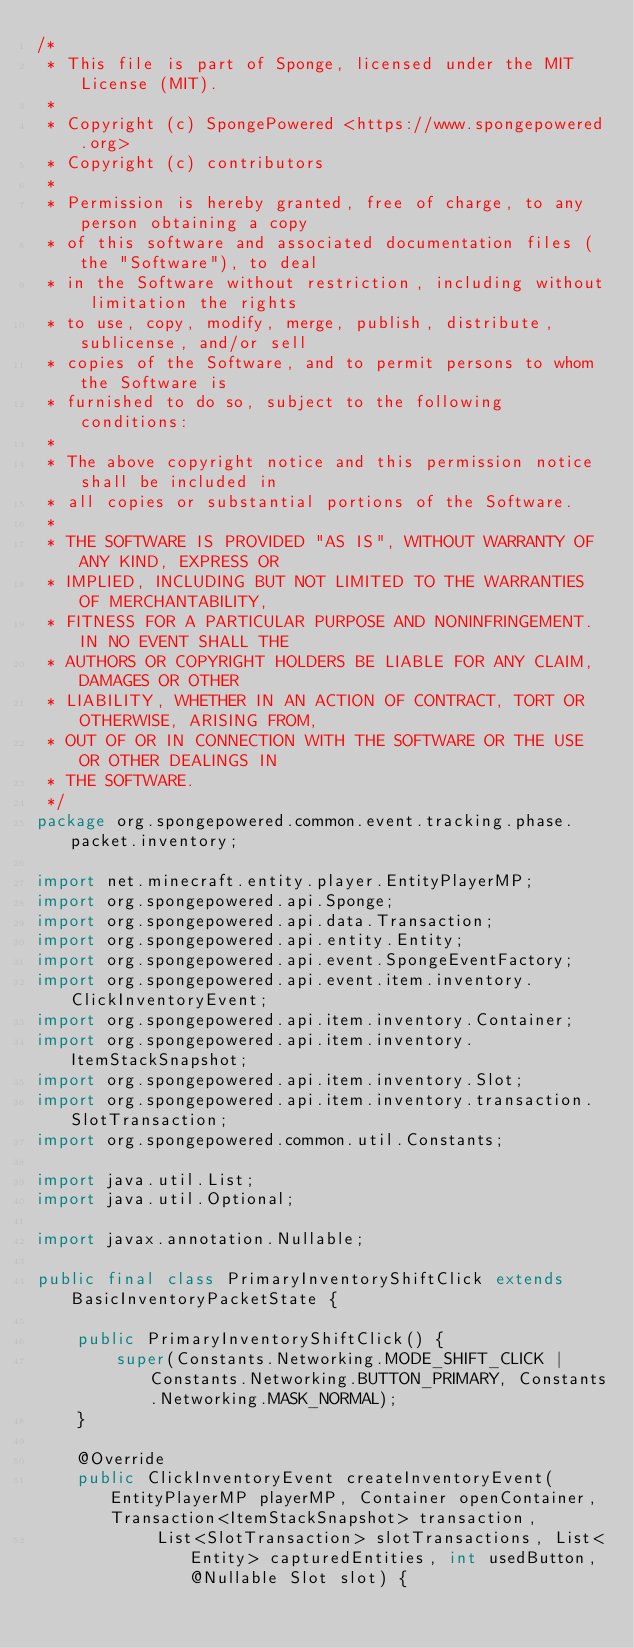<code> <loc_0><loc_0><loc_500><loc_500><_Java_>/*
 * This file is part of Sponge, licensed under the MIT License (MIT).
 *
 * Copyright (c) SpongePowered <https://www.spongepowered.org>
 * Copyright (c) contributors
 *
 * Permission is hereby granted, free of charge, to any person obtaining a copy
 * of this software and associated documentation files (the "Software"), to deal
 * in the Software without restriction, including without limitation the rights
 * to use, copy, modify, merge, publish, distribute, sublicense, and/or sell
 * copies of the Software, and to permit persons to whom the Software is
 * furnished to do so, subject to the following conditions:
 *
 * The above copyright notice and this permission notice shall be included in
 * all copies or substantial portions of the Software.
 *
 * THE SOFTWARE IS PROVIDED "AS IS", WITHOUT WARRANTY OF ANY KIND, EXPRESS OR
 * IMPLIED, INCLUDING BUT NOT LIMITED TO THE WARRANTIES OF MERCHANTABILITY,
 * FITNESS FOR A PARTICULAR PURPOSE AND NONINFRINGEMENT. IN NO EVENT SHALL THE
 * AUTHORS OR COPYRIGHT HOLDERS BE LIABLE FOR ANY CLAIM, DAMAGES OR OTHER
 * LIABILITY, WHETHER IN AN ACTION OF CONTRACT, TORT OR OTHERWISE, ARISING FROM,
 * OUT OF OR IN CONNECTION WITH THE SOFTWARE OR THE USE OR OTHER DEALINGS IN
 * THE SOFTWARE.
 */
package org.spongepowered.common.event.tracking.phase.packet.inventory;

import net.minecraft.entity.player.EntityPlayerMP;
import org.spongepowered.api.Sponge;
import org.spongepowered.api.data.Transaction;
import org.spongepowered.api.entity.Entity;
import org.spongepowered.api.event.SpongeEventFactory;
import org.spongepowered.api.event.item.inventory.ClickInventoryEvent;
import org.spongepowered.api.item.inventory.Container;
import org.spongepowered.api.item.inventory.ItemStackSnapshot;
import org.spongepowered.api.item.inventory.Slot;
import org.spongepowered.api.item.inventory.transaction.SlotTransaction;
import org.spongepowered.common.util.Constants;

import java.util.List;
import java.util.Optional;

import javax.annotation.Nullable;

public final class PrimaryInventoryShiftClick extends BasicInventoryPacketState {

    public PrimaryInventoryShiftClick() {
        super(Constants.Networking.MODE_SHIFT_CLICK | Constants.Networking.BUTTON_PRIMARY, Constants.Networking.MASK_NORMAL);
    }

    @Override
    public ClickInventoryEvent createInventoryEvent(EntityPlayerMP playerMP, Container openContainer, Transaction<ItemStackSnapshot> transaction,
            List<SlotTransaction> slotTransactions, List<Entity> capturedEntities, int usedButton, @Nullable Slot slot) {</code> 